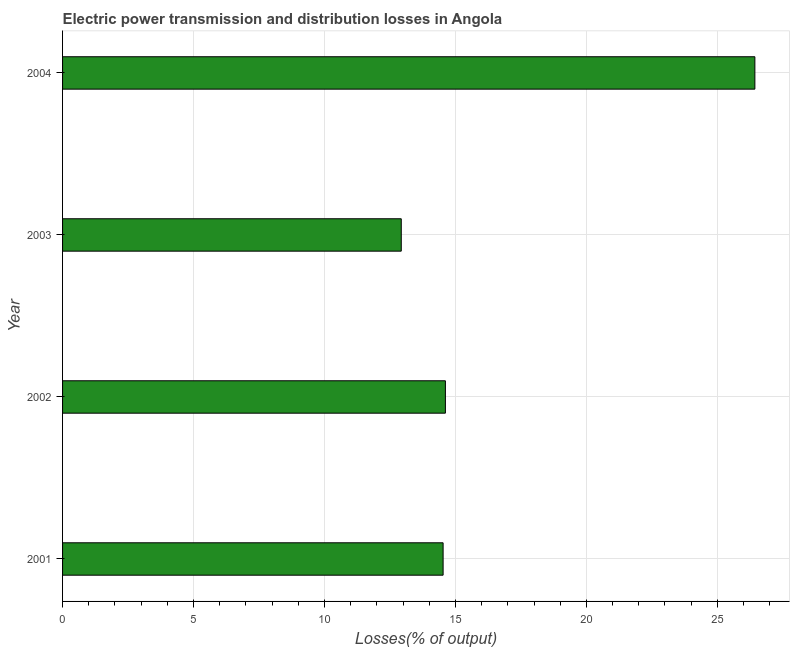Does the graph contain grids?
Offer a very short reply. Yes. What is the title of the graph?
Your answer should be very brief. Electric power transmission and distribution losses in Angola. What is the label or title of the X-axis?
Your answer should be very brief. Losses(% of output). What is the electric power transmission and distribution losses in 2003?
Offer a very short reply. 12.93. Across all years, what is the maximum electric power transmission and distribution losses?
Make the answer very short. 26.43. Across all years, what is the minimum electric power transmission and distribution losses?
Provide a short and direct response. 12.93. In which year was the electric power transmission and distribution losses maximum?
Your answer should be very brief. 2004. What is the sum of the electric power transmission and distribution losses?
Your answer should be very brief. 68.51. What is the difference between the electric power transmission and distribution losses in 2001 and 2002?
Provide a short and direct response. -0.09. What is the average electric power transmission and distribution losses per year?
Make the answer very short. 17.13. What is the median electric power transmission and distribution losses?
Offer a very short reply. 14.57. What is the ratio of the electric power transmission and distribution losses in 2003 to that in 2004?
Ensure brevity in your answer.  0.49. Is the electric power transmission and distribution losses in 2001 less than that in 2003?
Ensure brevity in your answer.  No. What is the difference between the highest and the second highest electric power transmission and distribution losses?
Provide a succinct answer. 11.82. Is the sum of the electric power transmission and distribution losses in 2001 and 2003 greater than the maximum electric power transmission and distribution losses across all years?
Your answer should be compact. Yes. Are all the bars in the graph horizontal?
Offer a terse response. Yes. How many years are there in the graph?
Offer a terse response. 4. Are the values on the major ticks of X-axis written in scientific E-notation?
Offer a terse response. No. What is the Losses(% of output) of 2001?
Keep it short and to the point. 14.53. What is the Losses(% of output) in 2002?
Your answer should be compact. 14.62. What is the Losses(% of output) of 2003?
Your response must be concise. 12.93. What is the Losses(% of output) of 2004?
Make the answer very short. 26.43. What is the difference between the Losses(% of output) in 2001 and 2002?
Give a very brief answer. -0.09. What is the difference between the Losses(% of output) in 2001 and 2003?
Your answer should be compact. 1.6. What is the difference between the Losses(% of output) in 2001 and 2004?
Provide a short and direct response. -11.9. What is the difference between the Losses(% of output) in 2002 and 2003?
Your answer should be very brief. 1.69. What is the difference between the Losses(% of output) in 2002 and 2004?
Your answer should be very brief. -11.82. What is the difference between the Losses(% of output) in 2003 and 2004?
Offer a very short reply. -13.5. What is the ratio of the Losses(% of output) in 2001 to that in 2003?
Give a very brief answer. 1.12. What is the ratio of the Losses(% of output) in 2001 to that in 2004?
Keep it short and to the point. 0.55. What is the ratio of the Losses(% of output) in 2002 to that in 2003?
Keep it short and to the point. 1.13. What is the ratio of the Losses(% of output) in 2002 to that in 2004?
Ensure brevity in your answer.  0.55. What is the ratio of the Losses(% of output) in 2003 to that in 2004?
Your answer should be very brief. 0.49. 